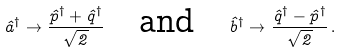Convert formula to latex. <formula><loc_0><loc_0><loc_500><loc_500>\hat { a } ^ { \dagger } \rightarrow \frac { \hat { p } ^ { \dagger } + \hat { q } ^ { \dagger } } { \sqrt { 2 } } \quad \text {and} \quad \hat { b } ^ { \dagger } \rightarrow \frac { \hat { q } ^ { \dagger } - \hat { p } ^ { \dagger } } { \sqrt { 2 } } \, .</formula> 